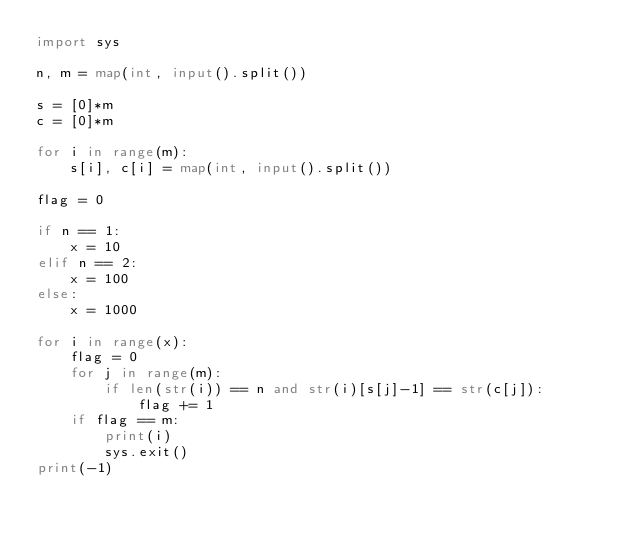Convert code to text. <code><loc_0><loc_0><loc_500><loc_500><_Python_>import sys

n, m = map(int, input().split())

s = [0]*m
c = [0]*m

for i in range(m):
    s[i], c[i] = map(int, input().split())

flag = 0

if n == 1:
    x = 10
elif n == 2:
    x = 100
else:
    x = 1000

for i in range(x):
    flag = 0
    for j in range(m):
        if len(str(i)) == n and str(i)[s[j]-1] == str(c[j]):
            flag += 1
    if flag == m:
        print(i)
        sys.exit()
print(-1)</code> 